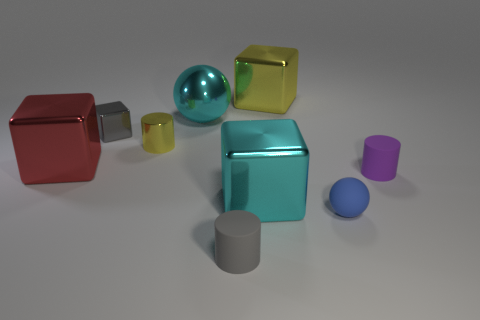Subtract all big yellow shiny blocks. How many blocks are left? 3 Subtract all gray cylinders. How many cylinders are left? 2 Subtract all balls. How many objects are left? 7 Subtract 1 spheres. How many spheres are left? 1 Add 5 big objects. How many big objects exist? 9 Subtract 1 cyan balls. How many objects are left? 8 Subtract all purple spheres. Subtract all cyan cubes. How many spheres are left? 2 Subtract all yellow spheres. How many yellow blocks are left? 1 Subtract all cyan metal things. Subtract all small yellow cylinders. How many objects are left? 6 Add 7 cyan metallic balls. How many cyan metallic balls are left? 8 